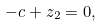<formula> <loc_0><loc_0><loc_500><loc_500>- c + z _ { 2 } = 0 ,</formula> 